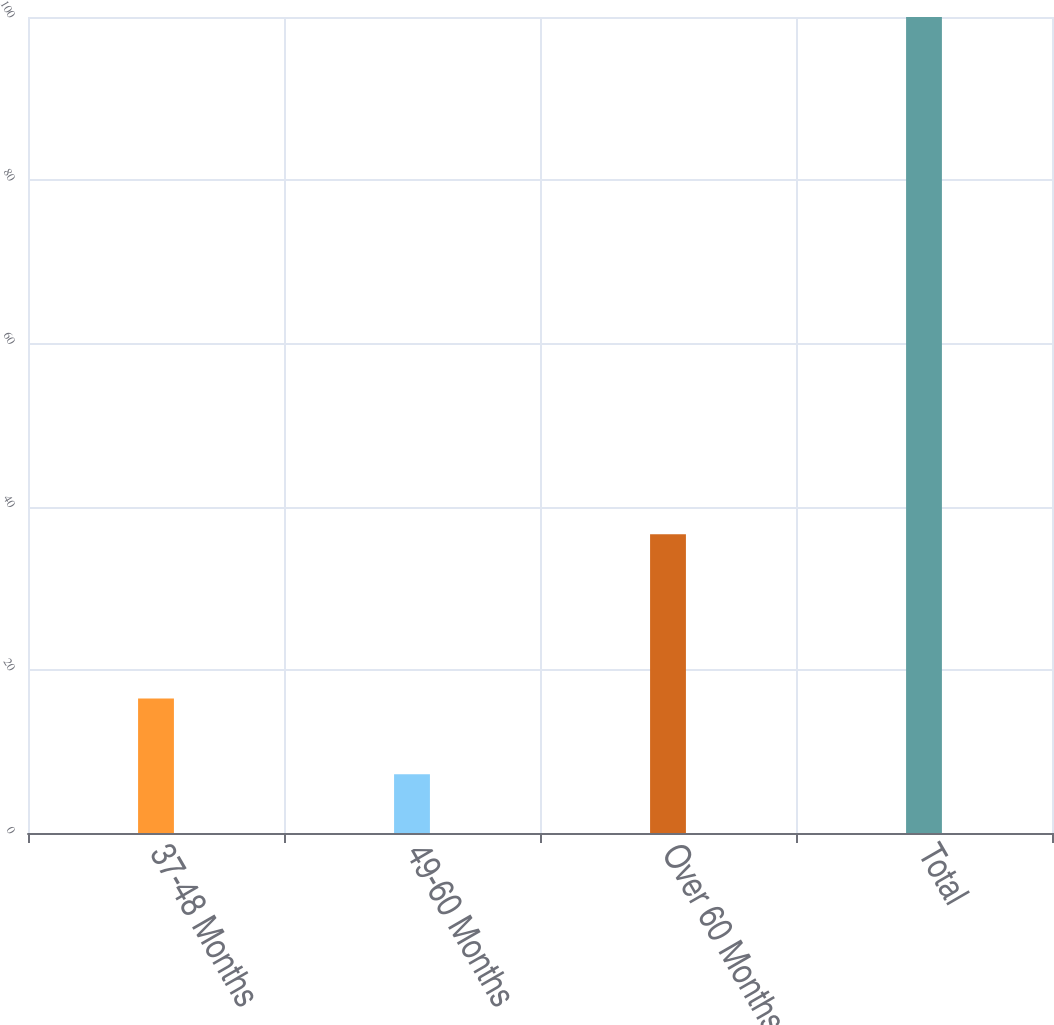Convert chart to OTSL. <chart><loc_0><loc_0><loc_500><loc_500><bar_chart><fcel>37-48 Months<fcel>49-60 Months<fcel>Over 60 Months<fcel>Total<nl><fcel>16.48<fcel>7.2<fcel>36.6<fcel>100<nl></chart> 